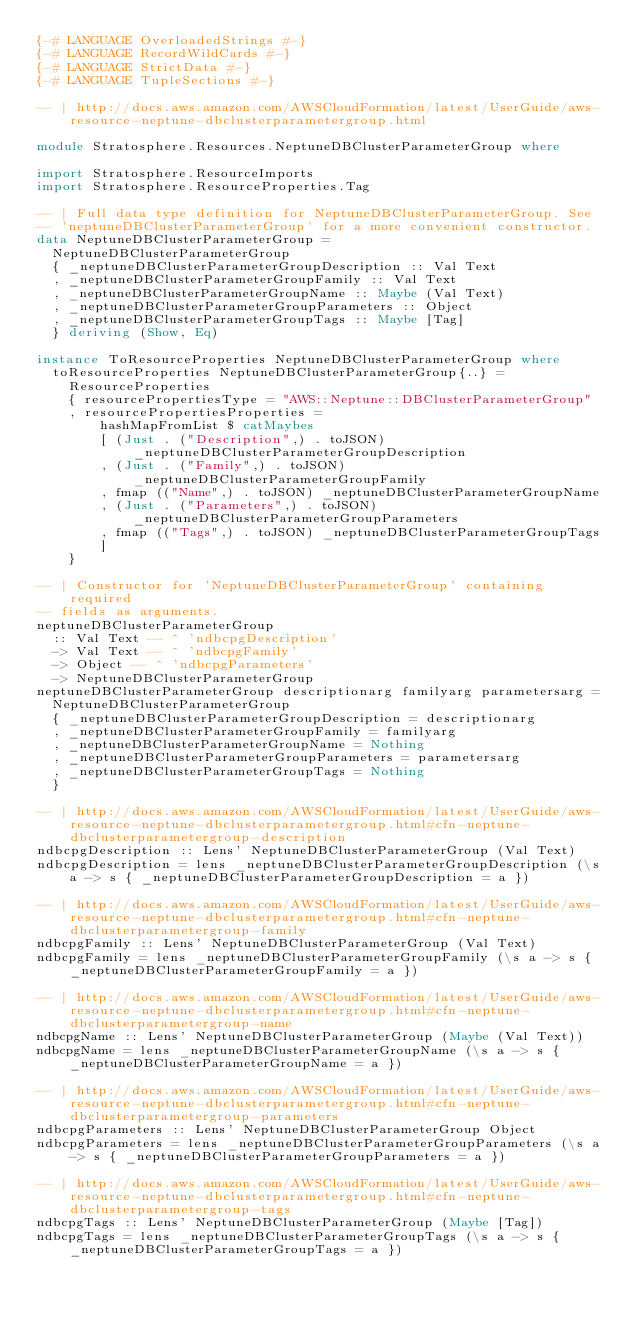Convert code to text. <code><loc_0><loc_0><loc_500><loc_500><_Haskell_>{-# LANGUAGE OverloadedStrings #-}
{-# LANGUAGE RecordWildCards #-}
{-# LANGUAGE StrictData #-}
{-# LANGUAGE TupleSections #-}

-- | http://docs.aws.amazon.com/AWSCloudFormation/latest/UserGuide/aws-resource-neptune-dbclusterparametergroup.html

module Stratosphere.Resources.NeptuneDBClusterParameterGroup where

import Stratosphere.ResourceImports
import Stratosphere.ResourceProperties.Tag

-- | Full data type definition for NeptuneDBClusterParameterGroup. See
-- 'neptuneDBClusterParameterGroup' for a more convenient constructor.
data NeptuneDBClusterParameterGroup =
  NeptuneDBClusterParameterGroup
  { _neptuneDBClusterParameterGroupDescription :: Val Text
  , _neptuneDBClusterParameterGroupFamily :: Val Text
  , _neptuneDBClusterParameterGroupName :: Maybe (Val Text)
  , _neptuneDBClusterParameterGroupParameters :: Object
  , _neptuneDBClusterParameterGroupTags :: Maybe [Tag]
  } deriving (Show, Eq)

instance ToResourceProperties NeptuneDBClusterParameterGroup where
  toResourceProperties NeptuneDBClusterParameterGroup{..} =
    ResourceProperties
    { resourcePropertiesType = "AWS::Neptune::DBClusterParameterGroup"
    , resourcePropertiesProperties =
        hashMapFromList $ catMaybes
        [ (Just . ("Description",) . toJSON) _neptuneDBClusterParameterGroupDescription
        , (Just . ("Family",) . toJSON) _neptuneDBClusterParameterGroupFamily
        , fmap (("Name",) . toJSON) _neptuneDBClusterParameterGroupName
        , (Just . ("Parameters",) . toJSON) _neptuneDBClusterParameterGroupParameters
        , fmap (("Tags",) . toJSON) _neptuneDBClusterParameterGroupTags
        ]
    }

-- | Constructor for 'NeptuneDBClusterParameterGroup' containing required
-- fields as arguments.
neptuneDBClusterParameterGroup
  :: Val Text -- ^ 'ndbcpgDescription'
  -> Val Text -- ^ 'ndbcpgFamily'
  -> Object -- ^ 'ndbcpgParameters'
  -> NeptuneDBClusterParameterGroup
neptuneDBClusterParameterGroup descriptionarg familyarg parametersarg =
  NeptuneDBClusterParameterGroup
  { _neptuneDBClusterParameterGroupDescription = descriptionarg
  , _neptuneDBClusterParameterGroupFamily = familyarg
  , _neptuneDBClusterParameterGroupName = Nothing
  , _neptuneDBClusterParameterGroupParameters = parametersarg
  , _neptuneDBClusterParameterGroupTags = Nothing
  }

-- | http://docs.aws.amazon.com/AWSCloudFormation/latest/UserGuide/aws-resource-neptune-dbclusterparametergroup.html#cfn-neptune-dbclusterparametergroup-description
ndbcpgDescription :: Lens' NeptuneDBClusterParameterGroup (Val Text)
ndbcpgDescription = lens _neptuneDBClusterParameterGroupDescription (\s a -> s { _neptuneDBClusterParameterGroupDescription = a })

-- | http://docs.aws.amazon.com/AWSCloudFormation/latest/UserGuide/aws-resource-neptune-dbclusterparametergroup.html#cfn-neptune-dbclusterparametergroup-family
ndbcpgFamily :: Lens' NeptuneDBClusterParameterGroup (Val Text)
ndbcpgFamily = lens _neptuneDBClusterParameterGroupFamily (\s a -> s { _neptuneDBClusterParameterGroupFamily = a })

-- | http://docs.aws.amazon.com/AWSCloudFormation/latest/UserGuide/aws-resource-neptune-dbclusterparametergroup.html#cfn-neptune-dbclusterparametergroup-name
ndbcpgName :: Lens' NeptuneDBClusterParameterGroup (Maybe (Val Text))
ndbcpgName = lens _neptuneDBClusterParameterGroupName (\s a -> s { _neptuneDBClusterParameterGroupName = a })

-- | http://docs.aws.amazon.com/AWSCloudFormation/latest/UserGuide/aws-resource-neptune-dbclusterparametergroup.html#cfn-neptune-dbclusterparametergroup-parameters
ndbcpgParameters :: Lens' NeptuneDBClusterParameterGroup Object
ndbcpgParameters = lens _neptuneDBClusterParameterGroupParameters (\s a -> s { _neptuneDBClusterParameterGroupParameters = a })

-- | http://docs.aws.amazon.com/AWSCloudFormation/latest/UserGuide/aws-resource-neptune-dbclusterparametergroup.html#cfn-neptune-dbclusterparametergroup-tags
ndbcpgTags :: Lens' NeptuneDBClusterParameterGroup (Maybe [Tag])
ndbcpgTags = lens _neptuneDBClusterParameterGroupTags (\s a -> s { _neptuneDBClusterParameterGroupTags = a })
</code> 